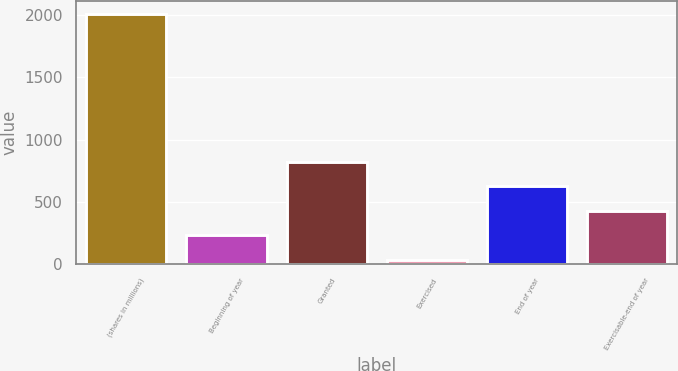<chart> <loc_0><loc_0><loc_500><loc_500><bar_chart><fcel>(shares in millions)<fcel>Beginning of year<fcel>Granted<fcel>Exercised<fcel>End of year<fcel>Exercisable-end of year<nl><fcel>2012<fcel>229.49<fcel>823.67<fcel>31.43<fcel>625.61<fcel>427.55<nl></chart> 